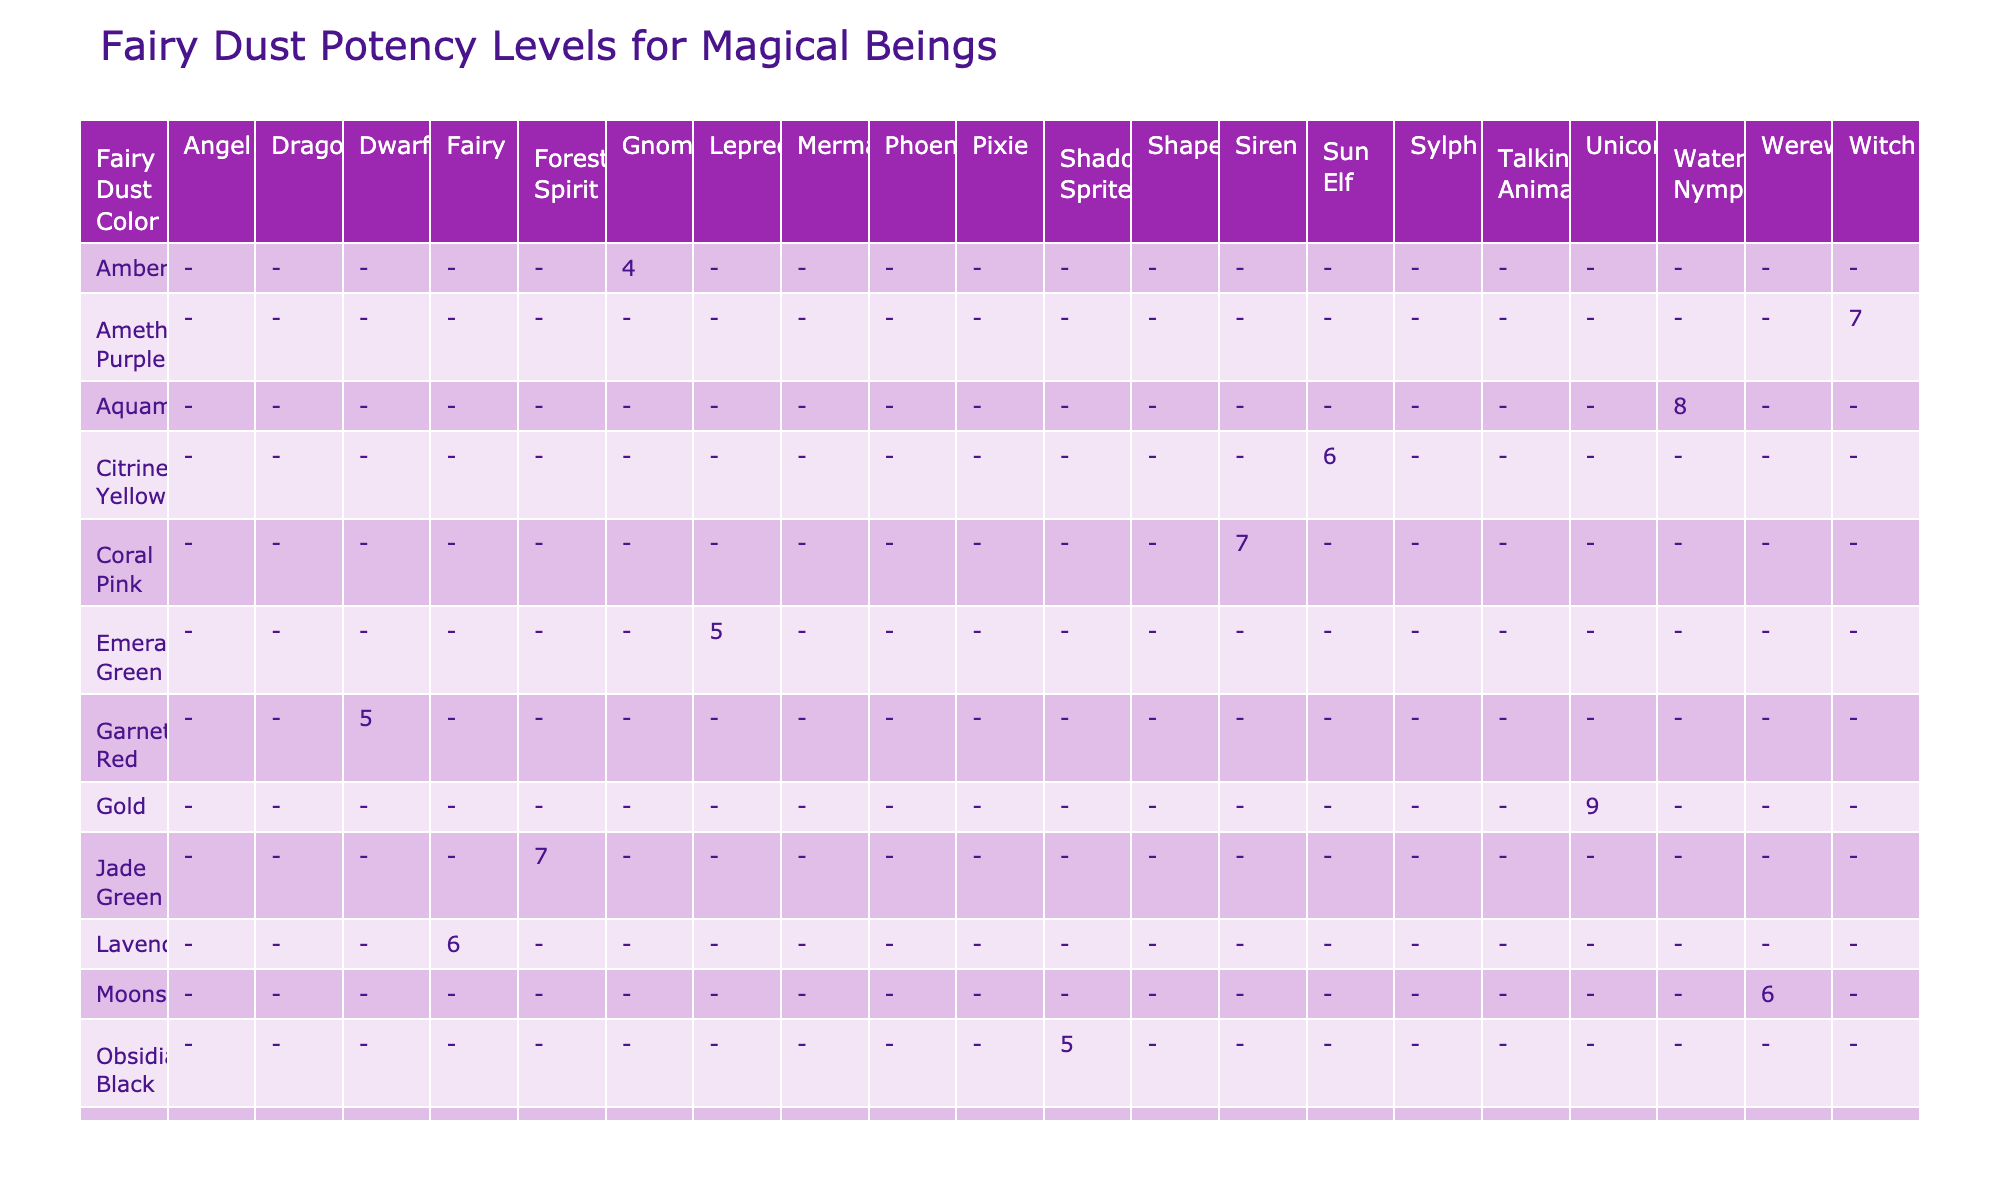What is the potency level of the Gold fairy dust for Unicorns? The table shows that the potency level associated with Gold fairy dust for Unicorns is 9.
Answer: 9 Which magical being has the highest potency level and what is that level? Looking through the table, Sapphire Blue for Dragons shows the highest potency level of 10.
Answer: 10 Is the potency level of Opal fairy dust for Shapeshifters higher than 7? The table reveals that the potency level of Opal fairy dust for Shapeshifters is 8, which is indeed higher than 7.
Answer: Yes What is the average potency level for the magical beings that are enhanced by gold, silver, and rose gold fairy dust? The potency levels for Gold, Silver, and Rose Gold are 9, 7, and 8, respectively. Adding these gives 9 + 7 + 8 = 24. Dividing by 3, the average potency level is 24 / 3 = 8.
Answer: 8 Which fairy dust color provides the longest duration and how long is it? From the table, Sapphire Blue for Dragons has the longest duration of 48 hours.
Answer: 48 hours Does any magical being have a potency level of 4? The table shows that Amber and Peridot fairy dust have potency levels of 4, hence the answer is yes.
Answer: Yes What are the primary effects of the fairy dust colors that have potency levels greater than 7? The fairy dust colors with potency levels greater than 7 are Gold (Enhanced Healing), Silver (Invisibility), Rose Gold (Underwater Breathing), Sapphire Blue (Fire Resistance), Ruby Red (Rebirth Acceleration), and Opal (Transformation Speed). Hence, the primary effects are as listed.
Answer: Enhanced Healing, Invisibility, Underwater Breathing, Fire Resistance, Rebirth Acceleration, Transformation Speed What is the difference in potency levels between the lowest and highest potency fairy dust colors? The lowest potency level observed is 4 (Amber and Peridot), and the highest is 10 (Sapphire Blue). The difference is calculated as 10 - 4 = 6.
Answer: 6 How many magical beings have a potency level of 5 or less? The table indicates that there are 3 magical beings (Emerald Green Leprechaun, Amber Gnome, and Peridot Talking Animal) with a potency level of 5 or less.
Answer: 3 